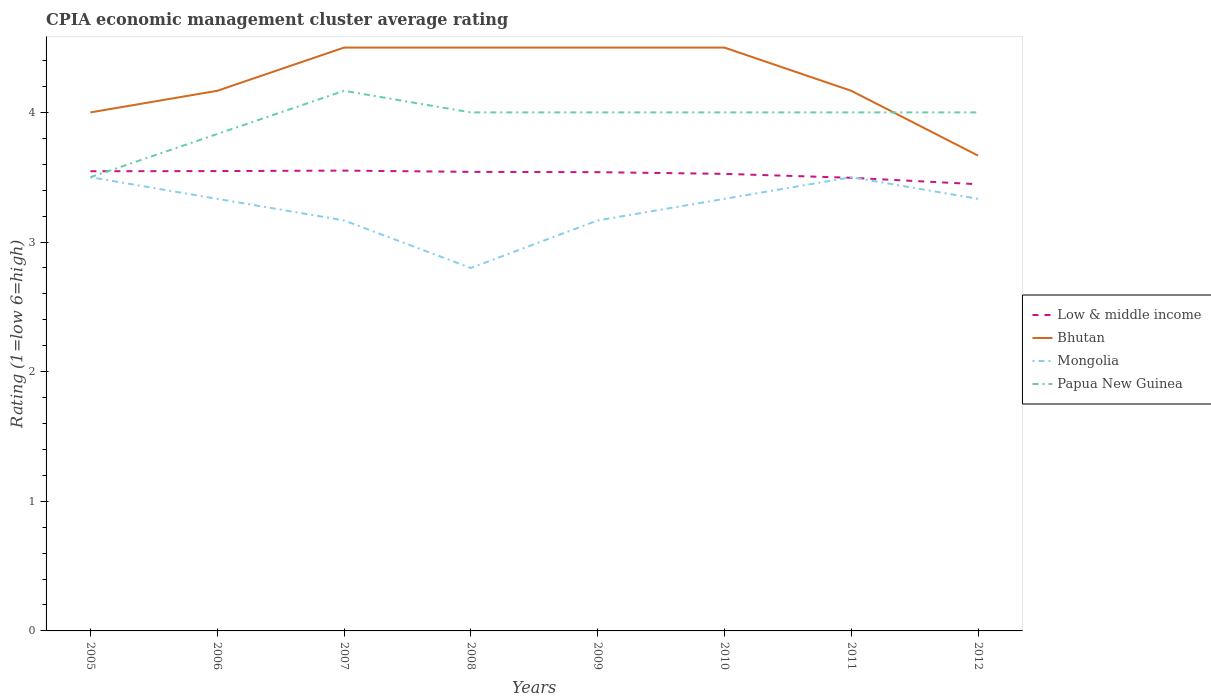Is the number of lines equal to the number of legend labels?
Your response must be concise. Yes. What is the total CPIA rating in Mongolia in the graph?
Your answer should be very brief. 0.17. What is the difference between the highest and the second highest CPIA rating in Low & middle income?
Keep it short and to the point. 0.11. What is the difference between the highest and the lowest CPIA rating in Low & middle income?
Give a very brief answer. 6. How many years are there in the graph?
Provide a succinct answer. 8. How many legend labels are there?
Give a very brief answer. 4. How are the legend labels stacked?
Ensure brevity in your answer.  Vertical. What is the title of the graph?
Your answer should be compact. CPIA economic management cluster average rating. Does "Slovenia" appear as one of the legend labels in the graph?
Make the answer very short. No. What is the Rating (1=low 6=high) in Low & middle income in 2005?
Offer a terse response. 3.55. What is the Rating (1=low 6=high) of Bhutan in 2005?
Ensure brevity in your answer.  4. What is the Rating (1=low 6=high) of Papua New Guinea in 2005?
Offer a very short reply. 3.5. What is the Rating (1=low 6=high) of Low & middle income in 2006?
Your response must be concise. 3.55. What is the Rating (1=low 6=high) of Bhutan in 2006?
Provide a short and direct response. 4.17. What is the Rating (1=low 6=high) in Mongolia in 2006?
Provide a short and direct response. 3.33. What is the Rating (1=low 6=high) in Papua New Guinea in 2006?
Offer a terse response. 3.83. What is the Rating (1=low 6=high) of Low & middle income in 2007?
Your answer should be compact. 3.55. What is the Rating (1=low 6=high) of Mongolia in 2007?
Ensure brevity in your answer.  3.17. What is the Rating (1=low 6=high) of Papua New Guinea in 2007?
Provide a succinct answer. 4.17. What is the Rating (1=low 6=high) in Low & middle income in 2008?
Your answer should be very brief. 3.54. What is the Rating (1=low 6=high) of Bhutan in 2008?
Offer a terse response. 4.5. What is the Rating (1=low 6=high) in Papua New Guinea in 2008?
Keep it short and to the point. 4. What is the Rating (1=low 6=high) of Low & middle income in 2009?
Give a very brief answer. 3.54. What is the Rating (1=low 6=high) of Bhutan in 2009?
Give a very brief answer. 4.5. What is the Rating (1=low 6=high) in Mongolia in 2009?
Make the answer very short. 3.17. What is the Rating (1=low 6=high) of Papua New Guinea in 2009?
Ensure brevity in your answer.  4. What is the Rating (1=low 6=high) of Low & middle income in 2010?
Your answer should be compact. 3.53. What is the Rating (1=low 6=high) in Mongolia in 2010?
Give a very brief answer. 3.33. What is the Rating (1=low 6=high) of Low & middle income in 2011?
Your answer should be compact. 3.5. What is the Rating (1=low 6=high) of Bhutan in 2011?
Make the answer very short. 4.17. What is the Rating (1=low 6=high) in Mongolia in 2011?
Provide a succinct answer. 3.5. What is the Rating (1=low 6=high) of Papua New Guinea in 2011?
Offer a terse response. 4. What is the Rating (1=low 6=high) in Low & middle income in 2012?
Keep it short and to the point. 3.45. What is the Rating (1=low 6=high) in Bhutan in 2012?
Give a very brief answer. 3.67. What is the Rating (1=low 6=high) in Mongolia in 2012?
Your answer should be compact. 3.33. What is the Rating (1=low 6=high) of Papua New Guinea in 2012?
Keep it short and to the point. 4. Across all years, what is the maximum Rating (1=low 6=high) in Low & middle income?
Make the answer very short. 3.55. Across all years, what is the maximum Rating (1=low 6=high) of Bhutan?
Make the answer very short. 4.5. Across all years, what is the maximum Rating (1=low 6=high) in Papua New Guinea?
Make the answer very short. 4.17. Across all years, what is the minimum Rating (1=low 6=high) of Low & middle income?
Ensure brevity in your answer.  3.45. Across all years, what is the minimum Rating (1=low 6=high) in Bhutan?
Offer a very short reply. 3.67. Across all years, what is the minimum Rating (1=low 6=high) of Mongolia?
Make the answer very short. 2.8. Across all years, what is the minimum Rating (1=low 6=high) in Papua New Guinea?
Make the answer very short. 3.5. What is the total Rating (1=low 6=high) of Low & middle income in the graph?
Your response must be concise. 28.19. What is the total Rating (1=low 6=high) of Mongolia in the graph?
Offer a very short reply. 26.13. What is the total Rating (1=low 6=high) in Papua New Guinea in the graph?
Provide a succinct answer. 31.5. What is the difference between the Rating (1=low 6=high) of Low & middle income in 2005 and that in 2006?
Your response must be concise. -0. What is the difference between the Rating (1=low 6=high) of Bhutan in 2005 and that in 2006?
Offer a terse response. -0.17. What is the difference between the Rating (1=low 6=high) of Mongolia in 2005 and that in 2006?
Provide a succinct answer. 0.17. What is the difference between the Rating (1=low 6=high) of Papua New Guinea in 2005 and that in 2006?
Provide a short and direct response. -0.33. What is the difference between the Rating (1=low 6=high) of Low & middle income in 2005 and that in 2007?
Offer a very short reply. -0.01. What is the difference between the Rating (1=low 6=high) in Papua New Guinea in 2005 and that in 2007?
Your answer should be very brief. -0.67. What is the difference between the Rating (1=low 6=high) of Low & middle income in 2005 and that in 2008?
Your answer should be very brief. 0. What is the difference between the Rating (1=low 6=high) of Bhutan in 2005 and that in 2008?
Your answer should be very brief. -0.5. What is the difference between the Rating (1=low 6=high) of Papua New Guinea in 2005 and that in 2008?
Your response must be concise. -0.5. What is the difference between the Rating (1=low 6=high) of Low & middle income in 2005 and that in 2009?
Offer a terse response. 0.01. What is the difference between the Rating (1=low 6=high) in Mongolia in 2005 and that in 2009?
Keep it short and to the point. 0.33. What is the difference between the Rating (1=low 6=high) of Papua New Guinea in 2005 and that in 2009?
Give a very brief answer. -0.5. What is the difference between the Rating (1=low 6=high) of Low & middle income in 2005 and that in 2010?
Give a very brief answer. 0.02. What is the difference between the Rating (1=low 6=high) of Papua New Guinea in 2005 and that in 2010?
Give a very brief answer. -0.5. What is the difference between the Rating (1=low 6=high) in Low & middle income in 2005 and that in 2011?
Keep it short and to the point. 0.05. What is the difference between the Rating (1=low 6=high) in Bhutan in 2005 and that in 2011?
Your response must be concise. -0.17. What is the difference between the Rating (1=low 6=high) in Low & middle income in 2005 and that in 2012?
Your answer should be compact. 0.1. What is the difference between the Rating (1=low 6=high) of Mongolia in 2005 and that in 2012?
Ensure brevity in your answer.  0.17. What is the difference between the Rating (1=low 6=high) in Papua New Guinea in 2005 and that in 2012?
Make the answer very short. -0.5. What is the difference between the Rating (1=low 6=high) in Low & middle income in 2006 and that in 2007?
Provide a short and direct response. -0. What is the difference between the Rating (1=low 6=high) of Papua New Guinea in 2006 and that in 2007?
Keep it short and to the point. -0.33. What is the difference between the Rating (1=low 6=high) in Low & middle income in 2006 and that in 2008?
Offer a very short reply. 0.01. What is the difference between the Rating (1=low 6=high) in Bhutan in 2006 and that in 2008?
Give a very brief answer. -0.33. What is the difference between the Rating (1=low 6=high) of Mongolia in 2006 and that in 2008?
Offer a very short reply. 0.53. What is the difference between the Rating (1=low 6=high) in Low & middle income in 2006 and that in 2009?
Ensure brevity in your answer.  0.01. What is the difference between the Rating (1=low 6=high) of Bhutan in 2006 and that in 2009?
Offer a very short reply. -0.33. What is the difference between the Rating (1=low 6=high) in Mongolia in 2006 and that in 2009?
Ensure brevity in your answer.  0.17. What is the difference between the Rating (1=low 6=high) in Papua New Guinea in 2006 and that in 2009?
Make the answer very short. -0.17. What is the difference between the Rating (1=low 6=high) of Low & middle income in 2006 and that in 2010?
Offer a very short reply. 0.02. What is the difference between the Rating (1=low 6=high) in Low & middle income in 2006 and that in 2011?
Provide a succinct answer. 0.05. What is the difference between the Rating (1=low 6=high) in Mongolia in 2006 and that in 2011?
Give a very brief answer. -0.17. What is the difference between the Rating (1=low 6=high) in Low & middle income in 2006 and that in 2012?
Your answer should be very brief. 0.1. What is the difference between the Rating (1=low 6=high) of Bhutan in 2006 and that in 2012?
Keep it short and to the point. 0.5. What is the difference between the Rating (1=low 6=high) of Mongolia in 2006 and that in 2012?
Provide a short and direct response. 0. What is the difference between the Rating (1=low 6=high) of Low & middle income in 2007 and that in 2008?
Give a very brief answer. 0.01. What is the difference between the Rating (1=low 6=high) in Mongolia in 2007 and that in 2008?
Give a very brief answer. 0.37. What is the difference between the Rating (1=low 6=high) in Low & middle income in 2007 and that in 2009?
Your answer should be compact. 0.01. What is the difference between the Rating (1=low 6=high) in Mongolia in 2007 and that in 2009?
Offer a terse response. 0. What is the difference between the Rating (1=low 6=high) of Low & middle income in 2007 and that in 2010?
Make the answer very short. 0.03. What is the difference between the Rating (1=low 6=high) in Bhutan in 2007 and that in 2010?
Provide a short and direct response. 0. What is the difference between the Rating (1=low 6=high) of Mongolia in 2007 and that in 2010?
Your answer should be compact. -0.17. What is the difference between the Rating (1=low 6=high) of Low & middle income in 2007 and that in 2011?
Keep it short and to the point. 0.06. What is the difference between the Rating (1=low 6=high) in Mongolia in 2007 and that in 2011?
Offer a terse response. -0.33. What is the difference between the Rating (1=low 6=high) of Papua New Guinea in 2007 and that in 2011?
Make the answer very short. 0.17. What is the difference between the Rating (1=low 6=high) of Low & middle income in 2007 and that in 2012?
Your answer should be compact. 0.11. What is the difference between the Rating (1=low 6=high) in Mongolia in 2007 and that in 2012?
Offer a terse response. -0.17. What is the difference between the Rating (1=low 6=high) in Papua New Guinea in 2007 and that in 2012?
Offer a very short reply. 0.17. What is the difference between the Rating (1=low 6=high) in Low & middle income in 2008 and that in 2009?
Your response must be concise. 0. What is the difference between the Rating (1=low 6=high) of Bhutan in 2008 and that in 2009?
Provide a succinct answer. 0. What is the difference between the Rating (1=low 6=high) of Mongolia in 2008 and that in 2009?
Keep it short and to the point. -0.37. What is the difference between the Rating (1=low 6=high) in Papua New Guinea in 2008 and that in 2009?
Give a very brief answer. 0. What is the difference between the Rating (1=low 6=high) in Low & middle income in 2008 and that in 2010?
Your answer should be compact. 0.02. What is the difference between the Rating (1=low 6=high) in Bhutan in 2008 and that in 2010?
Make the answer very short. 0. What is the difference between the Rating (1=low 6=high) in Mongolia in 2008 and that in 2010?
Offer a terse response. -0.53. What is the difference between the Rating (1=low 6=high) in Low & middle income in 2008 and that in 2011?
Offer a very short reply. 0.05. What is the difference between the Rating (1=low 6=high) in Bhutan in 2008 and that in 2011?
Your answer should be compact. 0.33. What is the difference between the Rating (1=low 6=high) in Papua New Guinea in 2008 and that in 2011?
Make the answer very short. 0. What is the difference between the Rating (1=low 6=high) in Low & middle income in 2008 and that in 2012?
Your response must be concise. 0.1. What is the difference between the Rating (1=low 6=high) in Bhutan in 2008 and that in 2012?
Give a very brief answer. 0.83. What is the difference between the Rating (1=low 6=high) in Mongolia in 2008 and that in 2012?
Provide a succinct answer. -0.53. What is the difference between the Rating (1=low 6=high) in Low & middle income in 2009 and that in 2010?
Ensure brevity in your answer.  0.01. What is the difference between the Rating (1=low 6=high) in Bhutan in 2009 and that in 2010?
Give a very brief answer. 0. What is the difference between the Rating (1=low 6=high) in Mongolia in 2009 and that in 2010?
Your answer should be very brief. -0.17. What is the difference between the Rating (1=low 6=high) in Papua New Guinea in 2009 and that in 2010?
Provide a short and direct response. 0. What is the difference between the Rating (1=low 6=high) in Low & middle income in 2009 and that in 2011?
Your answer should be compact. 0.04. What is the difference between the Rating (1=low 6=high) of Bhutan in 2009 and that in 2011?
Provide a short and direct response. 0.33. What is the difference between the Rating (1=low 6=high) in Low & middle income in 2009 and that in 2012?
Give a very brief answer. 0.09. What is the difference between the Rating (1=low 6=high) in Bhutan in 2009 and that in 2012?
Offer a terse response. 0.83. What is the difference between the Rating (1=low 6=high) in Low & middle income in 2010 and that in 2011?
Your answer should be compact. 0.03. What is the difference between the Rating (1=low 6=high) of Low & middle income in 2010 and that in 2012?
Offer a very short reply. 0.08. What is the difference between the Rating (1=low 6=high) of Bhutan in 2010 and that in 2012?
Give a very brief answer. 0.83. What is the difference between the Rating (1=low 6=high) of Low & middle income in 2011 and that in 2012?
Your answer should be compact. 0.05. What is the difference between the Rating (1=low 6=high) in Mongolia in 2011 and that in 2012?
Provide a short and direct response. 0.17. What is the difference between the Rating (1=low 6=high) of Low & middle income in 2005 and the Rating (1=low 6=high) of Bhutan in 2006?
Provide a short and direct response. -0.62. What is the difference between the Rating (1=low 6=high) in Low & middle income in 2005 and the Rating (1=low 6=high) in Mongolia in 2006?
Provide a succinct answer. 0.21. What is the difference between the Rating (1=low 6=high) of Low & middle income in 2005 and the Rating (1=low 6=high) of Papua New Guinea in 2006?
Make the answer very short. -0.29. What is the difference between the Rating (1=low 6=high) in Mongolia in 2005 and the Rating (1=low 6=high) in Papua New Guinea in 2006?
Offer a very short reply. -0.33. What is the difference between the Rating (1=low 6=high) in Low & middle income in 2005 and the Rating (1=low 6=high) in Bhutan in 2007?
Keep it short and to the point. -0.95. What is the difference between the Rating (1=low 6=high) of Low & middle income in 2005 and the Rating (1=low 6=high) of Mongolia in 2007?
Your answer should be compact. 0.38. What is the difference between the Rating (1=low 6=high) of Low & middle income in 2005 and the Rating (1=low 6=high) of Papua New Guinea in 2007?
Offer a very short reply. -0.62. What is the difference between the Rating (1=low 6=high) of Mongolia in 2005 and the Rating (1=low 6=high) of Papua New Guinea in 2007?
Provide a short and direct response. -0.67. What is the difference between the Rating (1=low 6=high) of Low & middle income in 2005 and the Rating (1=low 6=high) of Bhutan in 2008?
Offer a terse response. -0.95. What is the difference between the Rating (1=low 6=high) of Low & middle income in 2005 and the Rating (1=low 6=high) of Mongolia in 2008?
Provide a succinct answer. 0.75. What is the difference between the Rating (1=low 6=high) in Low & middle income in 2005 and the Rating (1=low 6=high) in Papua New Guinea in 2008?
Offer a terse response. -0.45. What is the difference between the Rating (1=low 6=high) in Bhutan in 2005 and the Rating (1=low 6=high) in Mongolia in 2008?
Provide a succinct answer. 1.2. What is the difference between the Rating (1=low 6=high) in Bhutan in 2005 and the Rating (1=low 6=high) in Papua New Guinea in 2008?
Your response must be concise. 0. What is the difference between the Rating (1=low 6=high) of Mongolia in 2005 and the Rating (1=low 6=high) of Papua New Guinea in 2008?
Provide a succinct answer. -0.5. What is the difference between the Rating (1=low 6=high) of Low & middle income in 2005 and the Rating (1=low 6=high) of Bhutan in 2009?
Your answer should be very brief. -0.95. What is the difference between the Rating (1=low 6=high) of Low & middle income in 2005 and the Rating (1=low 6=high) of Mongolia in 2009?
Your answer should be very brief. 0.38. What is the difference between the Rating (1=low 6=high) in Low & middle income in 2005 and the Rating (1=low 6=high) in Papua New Guinea in 2009?
Make the answer very short. -0.45. What is the difference between the Rating (1=low 6=high) in Mongolia in 2005 and the Rating (1=low 6=high) in Papua New Guinea in 2009?
Your answer should be compact. -0.5. What is the difference between the Rating (1=low 6=high) of Low & middle income in 2005 and the Rating (1=low 6=high) of Bhutan in 2010?
Keep it short and to the point. -0.95. What is the difference between the Rating (1=low 6=high) of Low & middle income in 2005 and the Rating (1=low 6=high) of Mongolia in 2010?
Provide a short and direct response. 0.21. What is the difference between the Rating (1=low 6=high) of Low & middle income in 2005 and the Rating (1=low 6=high) of Papua New Guinea in 2010?
Ensure brevity in your answer.  -0.45. What is the difference between the Rating (1=low 6=high) of Bhutan in 2005 and the Rating (1=low 6=high) of Mongolia in 2010?
Give a very brief answer. 0.67. What is the difference between the Rating (1=low 6=high) in Mongolia in 2005 and the Rating (1=low 6=high) in Papua New Guinea in 2010?
Your answer should be compact. -0.5. What is the difference between the Rating (1=low 6=high) in Low & middle income in 2005 and the Rating (1=low 6=high) in Bhutan in 2011?
Your response must be concise. -0.62. What is the difference between the Rating (1=low 6=high) of Low & middle income in 2005 and the Rating (1=low 6=high) of Mongolia in 2011?
Your answer should be very brief. 0.05. What is the difference between the Rating (1=low 6=high) in Low & middle income in 2005 and the Rating (1=low 6=high) in Papua New Guinea in 2011?
Make the answer very short. -0.45. What is the difference between the Rating (1=low 6=high) of Bhutan in 2005 and the Rating (1=low 6=high) of Mongolia in 2011?
Your answer should be compact. 0.5. What is the difference between the Rating (1=low 6=high) in Low & middle income in 2005 and the Rating (1=low 6=high) in Bhutan in 2012?
Ensure brevity in your answer.  -0.12. What is the difference between the Rating (1=low 6=high) in Low & middle income in 2005 and the Rating (1=low 6=high) in Mongolia in 2012?
Make the answer very short. 0.21. What is the difference between the Rating (1=low 6=high) of Low & middle income in 2005 and the Rating (1=low 6=high) of Papua New Guinea in 2012?
Offer a terse response. -0.45. What is the difference between the Rating (1=low 6=high) in Bhutan in 2005 and the Rating (1=low 6=high) in Mongolia in 2012?
Your response must be concise. 0.67. What is the difference between the Rating (1=low 6=high) in Bhutan in 2005 and the Rating (1=low 6=high) in Papua New Guinea in 2012?
Your response must be concise. 0. What is the difference between the Rating (1=low 6=high) of Mongolia in 2005 and the Rating (1=low 6=high) of Papua New Guinea in 2012?
Provide a succinct answer. -0.5. What is the difference between the Rating (1=low 6=high) of Low & middle income in 2006 and the Rating (1=low 6=high) of Bhutan in 2007?
Provide a short and direct response. -0.95. What is the difference between the Rating (1=low 6=high) of Low & middle income in 2006 and the Rating (1=low 6=high) of Mongolia in 2007?
Ensure brevity in your answer.  0.38. What is the difference between the Rating (1=low 6=high) of Low & middle income in 2006 and the Rating (1=low 6=high) of Papua New Guinea in 2007?
Give a very brief answer. -0.62. What is the difference between the Rating (1=low 6=high) of Low & middle income in 2006 and the Rating (1=low 6=high) of Bhutan in 2008?
Keep it short and to the point. -0.95. What is the difference between the Rating (1=low 6=high) in Low & middle income in 2006 and the Rating (1=low 6=high) in Mongolia in 2008?
Make the answer very short. 0.75. What is the difference between the Rating (1=low 6=high) in Low & middle income in 2006 and the Rating (1=low 6=high) in Papua New Guinea in 2008?
Give a very brief answer. -0.45. What is the difference between the Rating (1=low 6=high) of Bhutan in 2006 and the Rating (1=low 6=high) of Mongolia in 2008?
Your answer should be compact. 1.37. What is the difference between the Rating (1=low 6=high) of Bhutan in 2006 and the Rating (1=low 6=high) of Papua New Guinea in 2008?
Your answer should be compact. 0.17. What is the difference between the Rating (1=low 6=high) of Low & middle income in 2006 and the Rating (1=low 6=high) of Bhutan in 2009?
Your answer should be very brief. -0.95. What is the difference between the Rating (1=low 6=high) of Low & middle income in 2006 and the Rating (1=low 6=high) of Mongolia in 2009?
Provide a succinct answer. 0.38. What is the difference between the Rating (1=low 6=high) in Low & middle income in 2006 and the Rating (1=low 6=high) in Papua New Guinea in 2009?
Your answer should be compact. -0.45. What is the difference between the Rating (1=low 6=high) of Bhutan in 2006 and the Rating (1=low 6=high) of Papua New Guinea in 2009?
Ensure brevity in your answer.  0.17. What is the difference between the Rating (1=low 6=high) of Mongolia in 2006 and the Rating (1=low 6=high) of Papua New Guinea in 2009?
Your response must be concise. -0.67. What is the difference between the Rating (1=low 6=high) in Low & middle income in 2006 and the Rating (1=low 6=high) in Bhutan in 2010?
Your response must be concise. -0.95. What is the difference between the Rating (1=low 6=high) of Low & middle income in 2006 and the Rating (1=low 6=high) of Mongolia in 2010?
Ensure brevity in your answer.  0.21. What is the difference between the Rating (1=low 6=high) of Low & middle income in 2006 and the Rating (1=low 6=high) of Papua New Guinea in 2010?
Keep it short and to the point. -0.45. What is the difference between the Rating (1=low 6=high) of Bhutan in 2006 and the Rating (1=low 6=high) of Mongolia in 2010?
Keep it short and to the point. 0.83. What is the difference between the Rating (1=low 6=high) in Bhutan in 2006 and the Rating (1=low 6=high) in Papua New Guinea in 2010?
Give a very brief answer. 0.17. What is the difference between the Rating (1=low 6=high) of Mongolia in 2006 and the Rating (1=low 6=high) of Papua New Guinea in 2010?
Provide a short and direct response. -0.67. What is the difference between the Rating (1=low 6=high) in Low & middle income in 2006 and the Rating (1=low 6=high) in Bhutan in 2011?
Your answer should be very brief. -0.62. What is the difference between the Rating (1=low 6=high) in Low & middle income in 2006 and the Rating (1=low 6=high) in Mongolia in 2011?
Your response must be concise. 0.05. What is the difference between the Rating (1=low 6=high) of Low & middle income in 2006 and the Rating (1=low 6=high) of Papua New Guinea in 2011?
Keep it short and to the point. -0.45. What is the difference between the Rating (1=low 6=high) of Bhutan in 2006 and the Rating (1=low 6=high) of Mongolia in 2011?
Offer a terse response. 0.67. What is the difference between the Rating (1=low 6=high) of Bhutan in 2006 and the Rating (1=low 6=high) of Papua New Guinea in 2011?
Make the answer very short. 0.17. What is the difference between the Rating (1=low 6=high) in Low & middle income in 2006 and the Rating (1=low 6=high) in Bhutan in 2012?
Provide a short and direct response. -0.12. What is the difference between the Rating (1=low 6=high) in Low & middle income in 2006 and the Rating (1=low 6=high) in Mongolia in 2012?
Your answer should be compact. 0.21. What is the difference between the Rating (1=low 6=high) of Low & middle income in 2006 and the Rating (1=low 6=high) of Papua New Guinea in 2012?
Your response must be concise. -0.45. What is the difference between the Rating (1=low 6=high) of Mongolia in 2006 and the Rating (1=low 6=high) of Papua New Guinea in 2012?
Keep it short and to the point. -0.67. What is the difference between the Rating (1=low 6=high) in Low & middle income in 2007 and the Rating (1=low 6=high) in Bhutan in 2008?
Provide a succinct answer. -0.95. What is the difference between the Rating (1=low 6=high) of Low & middle income in 2007 and the Rating (1=low 6=high) of Mongolia in 2008?
Offer a very short reply. 0.75. What is the difference between the Rating (1=low 6=high) in Low & middle income in 2007 and the Rating (1=low 6=high) in Papua New Guinea in 2008?
Offer a terse response. -0.45. What is the difference between the Rating (1=low 6=high) of Bhutan in 2007 and the Rating (1=low 6=high) of Mongolia in 2008?
Provide a succinct answer. 1.7. What is the difference between the Rating (1=low 6=high) in Bhutan in 2007 and the Rating (1=low 6=high) in Papua New Guinea in 2008?
Offer a very short reply. 0.5. What is the difference between the Rating (1=low 6=high) of Mongolia in 2007 and the Rating (1=low 6=high) of Papua New Guinea in 2008?
Ensure brevity in your answer.  -0.83. What is the difference between the Rating (1=low 6=high) of Low & middle income in 2007 and the Rating (1=low 6=high) of Bhutan in 2009?
Offer a terse response. -0.95. What is the difference between the Rating (1=low 6=high) of Low & middle income in 2007 and the Rating (1=low 6=high) of Mongolia in 2009?
Keep it short and to the point. 0.38. What is the difference between the Rating (1=low 6=high) in Low & middle income in 2007 and the Rating (1=low 6=high) in Papua New Guinea in 2009?
Offer a terse response. -0.45. What is the difference between the Rating (1=low 6=high) in Bhutan in 2007 and the Rating (1=low 6=high) in Mongolia in 2009?
Your answer should be compact. 1.33. What is the difference between the Rating (1=low 6=high) in Mongolia in 2007 and the Rating (1=low 6=high) in Papua New Guinea in 2009?
Give a very brief answer. -0.83. What is the difference between the Rating (1=low 6=high) of Low & middle income in 2007 and the Rating (1=low 6=high) of Bhutan in 2010?
Give a very brief answer. -0.95. What is the difference between the Rating (1=low 6=high) of Low & middle income in 2007 and the Rating (1=low 6=high) of Mongolia in 2010?
Offer a terse response. 0.22. What is the difference between the Rating (1=low 6=high) in Low & middle income in 2007 and the Rating (1=low 6=high) in Papua New Guinea in 2010?
Ensure brevity in your answer.  -0.45. What is the difference between the Rating (1=low 6=high) of Bhutan in 2007 and the Rating (1=low 6=high) of Mongolia in 2010?
Provide a succinct answer. 1.17. What is the difference between the Rating (1=low 6=high) of Low & middle income in 2007 and the Rating (1=low 6=high) of Bhutan in 2011?
Provide a short and direct response. -0.62. What is the difference between the Rating (1=low 6=high) of Low & middle income in 2007 and the Rating (1=low 6=high) of Mongolia in 2011?
Offer a terse response. 0.05. What is the difference between the Rating (1=low 6=high) of Low & middle income in 2007 and the Rating (1=low 6=high) of Papua New Guinea in 2011?
Give a very brief answer. -0.45. What is the difference between the Rating (1=low 6=high) of Bhutan in 2007 and the Rating (1=low 6=high) of Mongolia in 2011?
Your answer should be very brief. 1. What is the difference between the Rating (1=low 6=high) in Mongolia in 2007 and the Rating (1=low 6=high) in Papua New Guinea in 2011?
Your answer should be very brief. -0.83. What is the difference between the Rating (1=low 6=high) in Low & middle income in 2007 and the Rating (1=low 6=high) in Bhutan in 2012?
Ensure brevity in your answer.  -0.12. What is the difference between the Rating (1=low 6=high) in Low & middle income in 2007 and the Rating (1=low 6=high) in Mongolia in 2012?
Offer a terse response. 0.22. What is the difference between the Rating (1=low 6=high) of Low & middle income in 2007 and the Rating (1=low 6=high) of Papua New Guinea in 2012?
Give a very brief answer. -0.45. What is the difference between the Rating (1=low 6=high) in Bhutan in 2007 and the Rating (1=low 6=high) in Mongolia in 2012?
Make the answer very short. 1.17. What is the difference between the Rating (1=low 6=high) of Bhutan in 2007 and the Rating (1=low 6=high) of Papua New Guinea in 2012?
Ensure brevity in your answer.  0.5. What is the difference between the Rating (1=low 6=high) in Low & middle income in 2008 and the Rating (1=low 6=high) in Bhutan in 2009?
Give a very brief answer. -0.96. What is the difference between the Rating (1=low 6=high) in Low & middle income in 2008 and the Rating (1=low 6=high) in Mongolia in 2009?
Provide a short and direct response. 0.37. What is the difference between the Rating (1=low 6=high) in Low & middle income in 2008 and the Rating (1=low 6=high) in Papua New Guinea in 2009?
Make the answer very short. -0.46. What is the difference between the Rating (1=low 6=high) of Bhutan in 2008 and the Rating (1=low 6=high) of Papua New Guinea in 2009?
Your response must be concise. 0.5. What is the difference between the Rating (1=low 6=high) of Mongolia in 2008 and the Rating (1=low 6=high) of Papua New Guinea in 2009?
Offer a very short reply. -1.2. What is the difference between the Rating (1=low 6=high) of Low & middle income in 2008 and the Rating (1=low 6=high) of Bhutan in 2010?
Give a very brief answer. -0.96. What is the difference between the Rating (1=low 6=high) in Low & middle income in 2008 and the Rating (1=low 6=high) in Mongolia in 2010?
Your answer should be very brief. 0.21. What is the difference between the Rating (1=low 6=high) of Low & middle income in 2008 and the Rating (1=low 6=high) of Papua New Guinea in 2010?
Make the answer very short. -0.46. What is the difference between the Rating (1=low 6=high) of Bhutan in 2008 and the Rating (1=low 6=high) of Mongolia in 2010?
Offer a terse response. 1.17. What is the difference between the Rating (1=low 6=high) of Low & middle income in 2008 and the Rating (1=low 6=high) of Bhutan in 2011?
Offer a terse response. -0.63. What is the difference between the Rating (1=low 6=high) in Low & middle income in 2008 and the Rating (1=low 6=high) in Mongolia in 2011?
Give a very brief answer. 0.04. What is the difference between the Rating (1=low 6=high) of Low & middle income in 2008 and the Rating (1=low 6=high) of Papua New Guinea in 2011?
Your answer should be very brief. -0.46. What is the difference between the Rating (1=low 6=high) in Bhutan in 2008 and the Rating (1=low 6=high) in Mongolia in 2011?
Offer a very short reply. 1. What is the difference between the Rating (1=low 6=high) of Bhutan in 2008 and the Rating (1=low 6=high) of Papua New Guinea in 2011?
Ensure brevity in your answer.  0.5. What is the difference between the Rating (1=low 6=high) of Low & middle income in 2008 and the Rating (1=low 6=high) of Bhutan in 2012?
Your answer should be very brief. -0.13. What is the difference between the Rating (1=low 6=high) of Low & middle income in 2008 and the Rating (1=low 6=high) of Mongolia in 2012?
Offer a very short reply. 0.21. What is the difference between the Rating (1=low 6=high) of Low & middle income in 2008 and the Rating (1=low 6=high) of Papua New Guinea in 2012?
Your response must be concise. -0.46. What is the difference between the Rating (1=low 6=high) in Bhutan in 2008 and the Rating (1=low 6=high) in Mongolia in 2012?
Make the answer very short. 1.17. What is the difference between the Rating (1=low 6=high) in Bhutan in 2008 and the Rating (1=low 6=high) in Papua New Guinea in 2012?
Keep it short and to the point. 0.5. What is the difference between the Rating (1=low 6=high) in Mongolia in 2008 and the Rating (1=low 6=high) in Papua New Guinea in 2012?
Provide a succinct answer. -1.2. What is the difference between the Rating (1=low 6=high) of Low & middle income in 2009 and the Rating (1=low 6=high) of Bhutan in 2010?
Keep it short and to the point. -0.96. What is the difference between the Rating (1=low 6=high) in Low & middle income in 2009 and the Rating (1=low 6=high) in Mongolia in 2010?
Provide a succinct answer. 0.21. What is the difference between the Rating (1=low 6=high) of Low & middle income in 2009 and the Rating (1=low 6=high) of Papua New Guinea in 2010?
Give a very brief answer. -0.46. What is the difference between the Rating (1=low 6=high) of Bhutan in 2009 and the Rating (1=low 6=high) of Papua New Guinea in 2010?
Offer a terse response. 0.5. What is the difference between the Rating (1=low 6=high) of Low & middle income in 2009 and the Rating (1=low 6=high) of Bhutan in 2011?
Your answer should be compact. -0.63. What is the difference between the Rating (1=low 6=high) in Low & middle income in 2009 and the Rating (1=low 6=high) in Mongolia in 2011?
Provide a short and direct response. 0.04. What is the difference between the Rating (1=low 6=high) in Low & middle income in 2009 and the Rating (1=low 6=high) in Papua New Guinea in 2011?
Your response must be concise. -0.46. What is the difference between the Rating (1=low 6=high) in Bhutan in 2009 and the Rating (1=low 6=high) in Papua New Guinea in 2011?
Keep it short and to the point. 0.5. What is the difference between the Rating (1=low 6=high) of Mongolia in 2009 and the Rating (1=low 6=high) of Papua New Guinea in 2011?
Provide a short and direct response. -0.83. What is the difference between the Rating (1=low 6=high) of Low & middle income in 2009 and the Rating (1=low 6=high) of Bhutan in 2012?
Make the answer very short. -0.13. What is the difference between the Rating (1=low 6=high) in Low & middle income in 2009 and the Rating (1=low 6=high) in Mongolia in 2012?
Provide a short and direct response. 0.21. What is the difference between the Rating (1=low 6=high) of Low & middle income in 2009 and the Rating (1=low 6=high) of Papua New Guinea in 2012?
Offer a terse response. -0.46. What is the difference between the Rating (1=low 6=high) in Bhutan in 2009 and the Rating (1=low 6=high) in Papua New Guinea in 2012?
Provide a short and direct response. 0.5. What is the difference between the Rating (1=low 6=high) of Mongolia in 2009 and the Rating (1=low 6=high) of Papua New Guinea in 2012?
Offer a very short reply. -0.83. What is the difference between the Rating (1=low 6=high) of Low & middle income in 2010 and the Rating (1=low 6=high) of Bhutan in 2011?
Keep it short and to the point. -0.64. What is the difference between the Rating (1=low 6=high) of Low & middle income in 2010 and the Rating (1=low 6=high) of Mongolia in 2011?
Your answer should be compact. 0.03. What is the difference between the Rating (1=low 6=high) in Low & middle income in 2010 and the Rating (1=low 6=high) in Papua New Guinea in 2011?
Your answer should be very brief. -0.47. What is the difference between the Rating (1=low 6=high) of Bhutan in 2010 and the Rating (1=low 6=high) of Mongolia in 2011?
Your response must be concise. 1. What is the difference between the Rating (1=low 6=high) of Bhutan in 2010 and the Rating (1=low 6=high) of Papua New Guinea in 2011?
Offer a very short reply. 0.5. What is the difference between the Rating (1=low 6=high) in Low & middle income in 2010 and the Rating (1=low 6=high) in Bhutan in 2012?
Your answer should be very brief. -0.14. What is the difference between the Rating (1=low 6=high) in Low & middle income in 2010 and the Rating (1=low 6=high) in Mongolia in 2012?
Provide a short and direct response. 0.19. What is the difference between the Rating (1=low 6=high) of Low & middle income in 2010 and the Rating (1=low 6=high) of Papua New Guinea in 2012?
Your answer should be compact. -0.47. What is the difference between the Rating (1=low 6=high) of Bhutan in 2010 and the Rating (1=low 6=high) of Mongolia in 2012?
Offer a terse response. 1.17. What is the difference between the Rating (1=low 6=high) of Mongolia in 2010 and the Rating (1=low 6=high) of Papua New Guinea in 2012?
Make the answer very short. -0.67. What is the difference between the Rating (1=low 6=high) in Low & middle income in 2011 and the Rating (1=low 6=high) in Bhutan in 2012?
Your response must be concise. -0.17. What is the difference between the Rating (1=low 6=high) in Low & middle income in 2011 and the Rating (1=low 6=high) in Mongolia in 2012?
Offer a very short reply. 0.16. What is the difference between the Rating (1=low 6=high) in Low & middle income in 2011 and the Rating (1=low 6=high) in Papua New Guinea in 2012?
Keep it short and to the point. -0.5. What is the difference between the Rating (1=low 6=high) of Bhutan in 2011 and the Rating (1=low 6=high) of Papua New Guinea in 2012?
Give a very brief answer. 0.17. What is the difference between the Rating (1=low 6=high) in Mongolia in 2011 and the Rating (1=low 6=high) in Papua New Guinea in 2012?
Provide a succinct answer. -0.5. What is the average Rating (1=low 6=high) of Low & middle income per year?
Your answer should be very brief. 3.52. What is the average Rating (1=low 6=high) of Bhutan per year?
Give a very brief answer. 4.25. What is the average Rating (1=low 6=high) in Mongolia per year?
Your answer should be compact. 3.27. What is the average Rating (1=low 6=high) of Papua New Guinea per year?
Your answer should be very brief. 3.94. In the year 2005, what is the difference between the Rating (1=low 6=high) in Low & middle income and Rating (1=low 6=high) in Bhutan?
Give a very brief answer. -0.45. In the year 2005, what is the difference between the Rating (1=low 6=high) in Low & middle income and Rating (1=low 6=high) in Mongolia?
Your answer should be very brief. 0.05. In the year 2005, what is the difference between the Rating (1=low 6=high) in Low & middle income and Rating (1=low 6=high) in Papua New Guinea?
Make the answer very short. 0.05. In the year 2005, what is the difference between the Rating (1=low 6=high) of Bhutan and Rating (1=low 6=high) of Mongolia?
Your answer should be compact. 0.5. In the year 2005, what is the difference between the Rating (1=low 6=high) of Mongolia and Rating (1=low 6=high) of Papua New Guinea?
Offer a very short reply. 0. In the year 2006, what is the difference between the Rating (1=low 6=high) in Low & middle income and Rating (1=low 6=high) in Bhutan?
Offer a terse response. -0.62. In the year 2006, what is the difference between the Rating (1=low 6=high) in Low & middle income and Rating (1=low 6=high) in Mongolia?
Give a very brief answer. 0.21. In the year 2006, what is the difference between the Rating (1=low 6=high) in Low & middle income and Rating (1=low 6=high) in Papua New Guinea?
Your response must be concise. -0.29. In the year 2006, what is the difference between the Rating (1=low 6=high) of Bhutan and Rating (1=low 6=high) of Papua New Guinea?
Give a very brief answer. 0.33. In the year 2007, what is the difference between the Rating (1=low 6=high) of Low & middle income and Rating (1=low 6=high) of Bhutan?
Your answer should be compact. -0.95. In the year 2007, what is the difference between the Rating (1=low 6=high) of Low & middle income and Rating (1=low 6=high) of Mongolia?
Ensure brevity in your answer.  0.38. In the year 2007, what is the difference between the Rating (1=low 6=high) of Low & middle income and Rating (1=low 6=high) of Papua New Guinea?
Your answer should be very brief. -0.62. In the year 2007, what is the difference between the Rating (1=low 6=high) of Bhutan and Rating (1=low 6=high) of Mongolia?
Provide a succinct answer. 1.33. In the year 2008, what is the difference between the Rating (1=low 6=high) of Low & middle income and Rating (1=low 6=high) of Bhutan?
Give a very brief answer. -0.96. In the year 2008, what is the difference between the Rating (1=low 6=high) of Low & middle income and Rating (1=low 6=high) of Mongolia?
Provide a succinct answer. 0.74. In the year 2008, what is the difference between the Rating (1=low 6=high) in Low & middle income and Rating (1=low 6=high) in Papua New Guinea?
Offer a terse response. -0.46. In the year 2008, what is the difference between the Rating (1=low 6=high) of Bhutan and Rating (1=low 6=high) of Mongolia?
Keep it short and to the point. 1.7. In the year 2009, what is the difference between the Rating (1=low 6=high) of Low & middle income and Rating (1=low 6=high) of Bhutan?
Provide a succinct answer. -0.96. In the year 2009, what is the difference between the Rating (1=low 6=high) of Low & middle income and Rating (1=low 6=high) of Mongolia?
Ensure brevity in your answer.  0.37. In the year 2009, what is the difference between the Rating (1=low 6=high) of Low & middle income and Rating (1=low 6=high) of Papua New Guinea?
Offer a terse response. -0.46. In the year 2009, what is the difference between the Rating (1=low 6=high) in Bhutan and Rating (1=low 6=high) in Mongolia?
Your answer should be very brief. 1.33. In the year 2009, what is the difference between the Rating (1=low 6=high) of Mongolia and Rating (1=low 6=high) of Papua New Guinea?
Your answer should be compact. -0.83. In the year 2010, what is the difference between the Rating (1=low 6=high) of Low & middle income and Rating (1=low 6=high) of Bhutan?
Give a very brief answer. -0.97. In the year 2010, what is the difference between the Rating (1=low 6=high) of Low & middle income and Rating (1=low 6=high) of Mongolia?
Offer a very short reply. 0.19. In the year 2010, what is the difference between the Rating (1=low 6=high) in Low & middle income and Rating (1=low 6=high) in Papua New Guinea?
Provide a succinct answer. -0.47. In the year 2011, what is the difference between the Rating (1=low 6=high) of Low & middle income and Rating (1=low 6=high) of Bhutan?
Provide a short and direct response. -0.67. In the year 2011, what is the difference between the Rating (1=low 6=high) of Low & middle income and Rating (1=low 6=high) of Mongolia?
Keep it short and to the point. -0. In the year 2011, what is the difference between the Rating (1=low 6=high) in Low & middle income and Rating (1=low 6=high) in Papua New Guinea?
Offer a very short reply. -0.5. In the year 2011, what is the difference between the Rating (1=low 6=high) of Bhutan and Rating (1=low 6=high) of Mongolia?
Make the answer very short. 0.67. In the year 2011, what is the difference between the Rating (1=low 6=high) in Bhutan and Rating (1=low 6=high) in Papua New Guinea?
Make the answer very short. 0.17. In the year 2012, what is the difference between the Rating (1=low 6=high) in Low & middle income and Rating (1=low 6=high) in Bhutan?
Give a very brief answer. -0.22. In the year 2012, what is the difference between the Rating (1=low 6=high) of Low & middle income and Rating (1=low 6=high) of Mongolia?
Offer a terse response. 0.11. In the year 2012, what is the difference between the Rating (1=low 6=high) of Low & middle income and Rating (1=low 6=high) of Papua New Guinea?
Provide a short and direct response. -0.55. In the year 2012, what is the difference between the Rating (1=low 6=high) of Mongolia and Rating (1=low 6=high) of Papua New Guinea?
Keep it short and to the point. -0.67. What is the ratio of the Rating (1=low 6=high) of Mongolia in 2005 to that in 2006?
Your response must be concise. 1.05. What is the ratio of the Rating (1=low 6=high) in Mongolia in 2005 to that in 2007?
Your answer should be compact. 1.11. What is the ratio of the Rating (1=low 6=high) of Papua New Guinea in 2005 to that in 2007?
Keep it short and to the point. 0.84. What is the ratio of the Rating (1=low 6=high) in Low & middle income in 2005 to that in 2008?
Your answer should be very brief. 1. What is the ratio of the Rating (1=low 6=high) in Bhutan in 2005 to that in 2008?
Your answer should be very brief. 0.89. What is the ratio of the Rating (1=low 6=high) in Mongolia in 2005 to that in 2008?
Your answer should be very brief. 1.25. What is the ratio of the Rating (1=low 6=high) of Bhutan in 2005 to that in 2009?
Ensure brevity in your answer.  0.89. What is the ratio of the Rating (1=low 6=high) in Mongolia in 2005 to that in 2009?
Make the answer very short. 1.11. What is the ratio of the Rating (1=low 6=high) of Papua New Guinea in 2005 to that in 2009?
Offer a terse response. 0.88. What is the ratio of the Rating (1=low 6=high) in Papua New Guinea in 2005 to that in 2010?
Ensure brevity in your answer.  0.88. What is the ratio of the Rating (1=low 6=high) of Low & middle income in 2005 to that in 2011?
Provide a succinct answer. 1.01. What is the ratio of the Rating (1=low 6=high) in Low & middle income in 2005 to that in 2012?
Give a very brief answer. 1.03. What is the ratio of the Rating (1=low 6=high) in Bhutan in 2005 to that in 2012?
Ensure brevity in your answer.  1.09. What is the ratio of the Rating (1=low 6=high) in Low & middle income in 2006 to that in 2007?
Make the answer very short. 1. What is the ratio of the Rating (1=low 6=high) in Bhutan in 2006 to that in 2007?
Provide a succinct answer. 0.93. What is the ratio of the Rating (1=low 6=high) of Mongolia in 2006 to that in 2007?
Keep it short and to the point. 1.05. What is the ratio of the Rating (1=low 6=high) in Bhutan in 2006 to that in 2008?
Offer a very short reply. 0.93. What is the ratio of the Rating (1=low 6=high) of Mongolia in 2006 to that in 2008?
Make the answer very short. 1.19. What is the ratio of the Rating (1=low 6=high) of Low & middle income in 2006 to that in 2009?
Ensure brevity in your answer.  1. What is the ratio of the Rating (1=low 6=high) in Bhutan in 2006 to that in 2009?
Make the answer very short. 0.93. What is the ratio of the Rating (1=low 6=high) of Mongolia in 2006 to that in 2009?
Provide a short and direct response. 1.05. What is the ratio of the Rating (1=low 6=high) of Papua New Guinea in 2006 to that in 2009?
Your answer should be very brief. 0.96. What is the ratio of the Rating (1=low 6=high) in Bhutan in 2006 to that in 2010?
Keep it short and to the point. 0.93. What is the ratio of the Rating (1=low 6=high) of Low & middle income in 2006 to that in 2011?
Keep it short and to the point. 1.01. What is the ratio of the Rating (1=low 6=high) in Mongolia in 2006 to that in 2011?
Offer a very short reply. 0.95. What is the ratio of the Rating (1=low 6=high) in Papua New Guinea in 2006 to that in 2011?
Provide a short and direct response. 0.96. What is the ratio of the Rating (1=low 6=high) in Low & middle income in 2006 to that in 2012?
Provide a short and direct response. 1.03. What is the ratio of the Rating (1=low 6=high) of Bhutan in 2006 to that in 2012?
Provide a short and direct response. 1.14. What is the ratio of the Rating (1=low 6=high) of Mongolia in 2006 to that in 2012?
Your response must be concise. 1. What is the ratio of the Rating (1=low 6=high) of Papua New Guinea in 2006 to that in 2012?
Provide a short and direct response. 0.96. What is the ratio of the Rating (1=low 6=high) in Mongolia in 2007 to that in 2008?
Provide a succinct answer. 1.13. What is the ratio of the Rating (1=low 6=high) in Papua New Guinea in 2007 to that in 2008?
Keep it short and to the point. 1.04. What is the ratio of the Rating (1=low 6=high) in Papua New Guinea in 2007 to that in 2009?
Give a very brief answer. 1.04. What is the ratio of the Rating (1=low 6=high) of Low & middle income in 2007 to that in 2010?
Give a very brief answer. 1.01. What is the ratio of the Rating (1=low 6=high) of Mongolia in 2007 to that in 2010?
Make the answer very short. 0.95. What is the ratio of the Rating (1=low 6=high) of Papua New Guinea in 2007 to that in 2010?
Keep it short and to the point. 1.04. What is the ratio of the Rating (1=low 6=high) in Low & middle income in 2007 to that in 2011?
Your answer should be compact. 1.02. What is the ratio of the Rating (1=low 6=high) in Mongolia in 2007 to that in 2011?
Give a very brief answer. 0.9. What is the ratio of the Rating (1=low 6=high) of Papua New Guinea in 2007 to that in 2011?
Your answer should be compact. 1.04. What is the ratio of the Rating (1=low 6=high) in Low & middle income in 2007 to that in 2012?
Your response must be concise. 1.03. What is the ratio of the Rating (1=low 6=high) of Bhutan in 2007 to that in 2012?
Your answer should be compact. 1.23. What is the ratio of the Rating (1=low 6=high) of Papua New Guinea in 2007 to that in 2012?
Your answer should be compact. 1.04. What is the ratio of the Rating (1=low 6=high) of Mongolia in 2008 to that in 2009?
Your answer should be very brief. 0.88. What is the ratio of the Rating (1=low 6=high) in Low & middle income in 2008 to that in 2010?
Make the answer very short. 1. What is the ratio of the Rating (1=low 6=high) in Mongolia in 2008 to that in 2010?
Offer a terse response. 0.84. What is the ratio of the Rating (1=low 6=high) of Low & middle income in 2008 to that in 2011?
Your answer should be very brief. 1.01. What is the ratio of the Rating (1=low 6=high) in Papua New Guinea in 2008 to that in 2011?
Make the answer very short. 1. What is the ratio of the Rating (1=low 6=high) in Low & middle income in 2008 to that in 2012?
Offer a terse response. 1.03. What is the ratio of the Rating (1=low 6=high) in Bhutan in 2008 to that in 2012?
Provide a short and direct response. 1.23. What is the ratio of the Rating (1=low 6=high) in Mongolia in 2008 to that in 2012?
Your answer should be compact. 0.84. What is the ratio of the Rating (1=low 6=high) of Papua New Guinea in 2008 to that in 2012?
Provide a succinct answer. 1. What is the ratio of the Rating (1=low 6=high) of Bhutan in 2009 to that in 2010?
Provide a succinct answer. 1. What is the ratio of the Rating (1=low 6=high) of Papua New Guinea in 2009 to that in 2010?
Your response must be concise. 1. What is the ratio of the Rating (1=low 6=high) of Low & middle income in 2009 to that in 2011?
Offer a very short reply. 1.01. What is the ratio of the Rating (1=low 6=high) of Mongolia in 2009 to that in 2011?
Give a very brief answer. 0.9. What is the ratio of the Rating (1=low 6=high) in Bhutan in 2009 to that in 2012?
Your response must be concise. 1.23. What is the ratio of the Rating (1=low 6=high) of Mongolia in 2009 to that in 2012?
Keep it short and to the point. 0.95. What is the ratio of the Rating (1=low 6=high) in Papua New Guinea in 2009 to that in 2012?
Make the answer very short. 1. What is the ratio of the Rating (1=low 6=high) in Low & middle income in 2010 to that in 2011?
Your answer should be very brief. 1.01. What is the ratio of the Rating (1=low 6=high) in Bhutan in 2010 to that in 2011?
Make the answer very short. 1.08. What is the ratio of the Rating (1=low 6=high) of Low & middle income in 2010 to that in 2012?
Make the answer very short. 1.02. What is the ratio of the Rating (1=low 6=high) of Bhutan in 2010 to that in 2012?
Your response must be concise. 1.23. What is the ratio of the Rating (1=low 6=high) of Low & middle income in 2011 to that in 2012?
Ensure brevity in your answer.  1.01. What is the ratio of the Rating (1=low 6=high) in Bhutan in 2011 to that in 2012?
Offer a very short reply. 1.14. What is the ratio of the Rating (1=low 6=high) in Papua New Guinea in 2011 to that in 2012?
Your answer should be compact. 1. What is the difference between the highest and the second highest Rating (1=low 6=high) in Low & middle income?
Make the answer very short. 0. What is the difference between the highest and the second highest Rating (1=low 6=high) of Mongolia?
Your answer should be very brief. 0. What is the difference between the highest and the lowest Rating (1=low 6=high) of Low & middle income?
Keep it short and to the point. 0.11. What is the difference between the highest and the lowest Rating (1=low 6=high) of Papua New Guinea?
Ensure brevity in your answer.  0.67. 